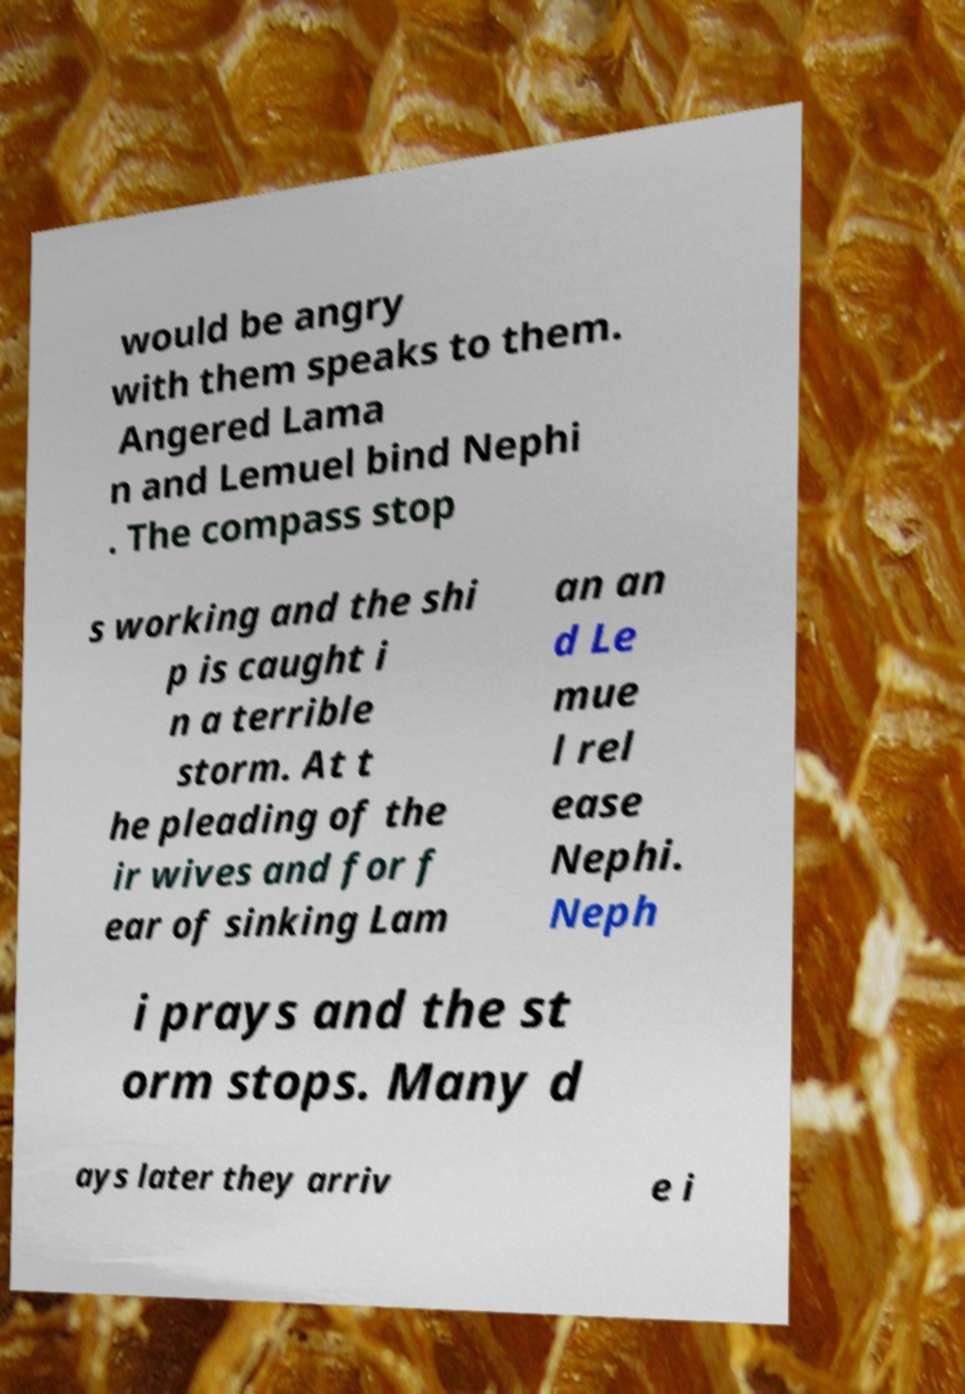There's text embedded in this image that I need extracted. Can you transcribe it verbatim? would be angry with them speaks to them. Angered Lama n and Lemuel bind Nephi . The compass stop s working and the shi p is caught i n a terrible storm. At t he pleading of the ir wives and for f ear of sinking Lam an an d Le mue l rel ease Nephi. Neph i prays and the st orm stops. Many d ays later they arriv e i 